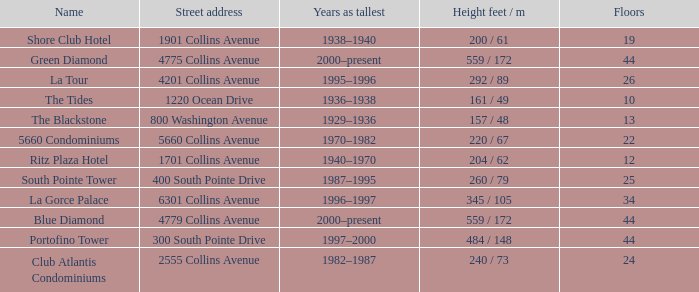How many floors does the Blue Diamond have? 44.0. 